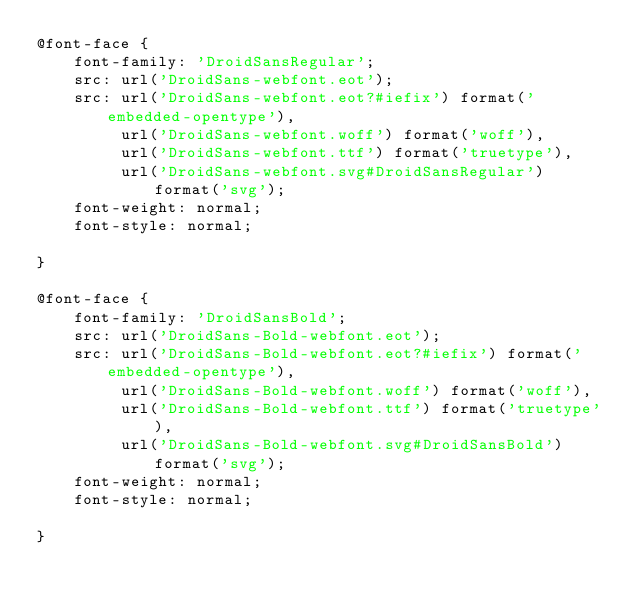<code> <loc_0><loc_0><loc_500><loc_500><_CSS_>@font-face {
    font-family: 'DroidSansRegular';
    src: url('DroidSans-webfont.eot');
    src: url('DroidSans-webfont.eot?#iefix') format('embedded-opentype'),
         url('DroidSans-webfont.woff') format('woff'),
         url('DroidSans-webfont.ttf') format('truetype'),
         url('DroidSans-webfont.svg#DroidSansRegular') format('svg');
    font-weight: normal;
    font-style: normal;

}

@font-face {
    font-family: 'DroidSansBold';
    src: url('DroidSans-Bold-webfont.eot');
    src: url('DroidSans-Bold-webfont.eot?#iefix') format('embedded-opentype'),
         url('DroidSans-Bold-webfont.woff') format('woff'),
         url('DroidSans-Bold-webfont.ttf') format('truetype'),
         url('DroidSans-Bold-webfont.svg#DroidSansBold') format('svg');
    font-weight: normal;
    font-style: normal;

}

</code> 